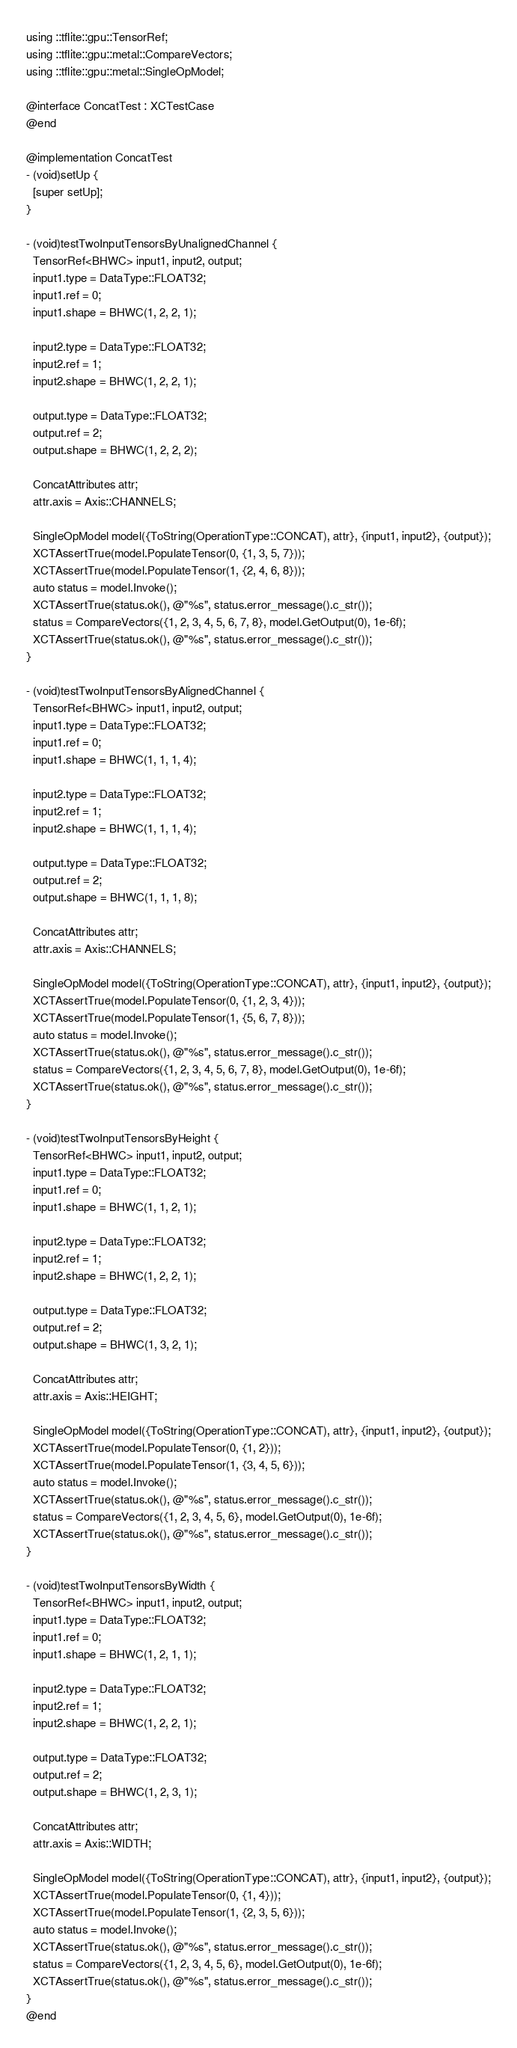Convert code to text. <code><loc_0><loc_0><loc_500><loc_500><_ObjectiveC_>using ::tflite::gpu::TensorRef;
using ::tflite::gpu::metal::CompareVectors;
using ::tflite::gpu::metal::SingleOpModel;

@interface ConcatTest : XCTestCase
@end

@implementation ConcatTest
- (void)setUp {
  [super setUp];
}

- (void)testTwoInputTensorsByUnalignedChannel {
  TensorRef<BHWC> input1, input2, output;
  input1.type = DataType::FLOAT32;
  input1.ref = 0;
  input1.shape = BHWC(1, 2, 2, 1);

  input2.type = DataType::FLOAT32;
  input2.ref = 1;
  input2.shape = BHWC(1, 2, 2, 1);

  output.type = DataType::FLOAT32;
  output.ref = 2;
  output.shape = BHWC(1, 2, 2, 2);

  ConcatAttributes attr;
  attr.axis = Axis::CHANNELS;

  SingleOpModel model({ToString(OperationType::CONCAT), attr}, {input1, input2}, {output});
  XCTAssertTrue(model.PopulateTensor(0, {1, 3, 5, 7}));
  XCTAssertTrue(model.PopulateTensor(1, {2, 4, 6, 8}));
  auto status = model.Invoke();
  XCTAssertTrue(status.ok(), @"%s", status.error_message().c_str());
  status = CompareVectors({1, 2, 3, 4, 5, 6, 7, 8}, model.GetOutput(0), 1e-6f);
  XCTAssertTrue(status.ok(), @"%s", status.error_message().c_str());
}

- (void)testTwoInputTensorsByAlignedChannel {
  TensorRef<BHWC> input1, input2, output;
  input1.type = DataType::FLOAT32;
  input1.ref = 0;
  input1.shape = BHWC(1, 1, 1, 4);

  input2.type = DataType::FLOAT32;
  input2.ref = 1;
  input2.shape = BHWC(1, 1, 1, 4);

  output.type = DataType::FLOAT32;
  output.ref = 2;
  output.shape = BHWC(1, 1, 1, 8);

  ConcatAttributes attr;
  attr.axis = Axis::CHANNELS;

  SingleOpModel model({ToString(OperationType::CONCAT), attr}, {input1, input2}, {output});
  XCTAssertTrue(model.PopulateTensor(0, {1, 2, 3, 4}));
  XCTAssertTrue(model.PopulateTensor(1, {5, 6, 7, 8}));
  auto status = model.Invoke();
  XCTAssertTrue(status.ok(), @"%s", status.error_message().c_str());
  status = CompareVectors({1, 2, 3, 4, 5, 6, 7, 8}, model.GetOutput(0), 1e-6f);
  XCTAssertTrue(status.ok(), @"%s", status.error_message().c_str());
}

- (void)testTwoInputTensorsByHeight {
  TensorRef<BHWC> input1, input2, output;
  input1.type = DataType::FLOAT32;
  input1.ref = 0;
  input1.shape = BHWC(1, 1, 2, 1);

  input2.type = DataType::FLOAT32;
  input2.ref = 1;
  input2.shape = BHWC(1, 2, 2, 1);

  output.type = DataType::FLOAT32;
  output.ref = 2;
  output.shape = BHWC(1, 3, 2, 1);

  ConcatAttributes attr;
  attr.axis = Axis::HEIGHT;

  SingleOpModel model({ToString(OperationType::CONCAT), attr}, {input1, input2}, {output});
  XCTAssertTrue(model.PopulateTensor(0, {1, 2}));
  XCTAssertTrue(model.PopulateTensor(1, {3, 4, 5, 6}));
  auto status = model.Invoke();
  XCTAssertTrue(status.ok(), @"%s", status.error_message().c_str());
  status = CompareVectors({1, 2, 3, 4, 5, 6}, model.GetOutput(0), 1e-6f);
  XCTAssertTrue(status.ok(), @"%s", status.error_message().c_str());
}

- (void)testTwoInputTensorsByWidth {
  TensorRef<BHWC> input1, input2, output;
  input1.type = DataType::FLOAT32;
  input1.ref = 0;
  input1.shape = BHWC(1, 2, 1, 1);

  input2.type = DataType::FLOAT32;
  input2.ref = 1;
  input2.shape = BHWC(1, 2, 2, 1);

  output.type = DataType::FLOAT32;
  output.ref = 2;
  output.shape = BHWC(1, 2, 3, 1);

  ConcatAttributes attr;
  attr.axis = Axis::WIDTH;

  SingleOpModel model({ToString(OperationType::CONCAT), attr}, {input1, input2}, {output});
  XCTAssertTrue(model.PopulateTensor(0, {1, 4}));
  XCTAssertTrue(model.PopulateTensor(1, {2, 3, 5, 6}));
  auto status = model.Invoke();
  XCTAssertTrue(status.ok(), @"%s", status.error_message().c_str());
  status = CompareVectors({1, 2, 3, 4, 5, 6}, model.GetOutput(0), 1e-6f);
  XCTAssertTrue(status.ok(), @"%s", status.error_message().c_str());
}
@end
</code> 